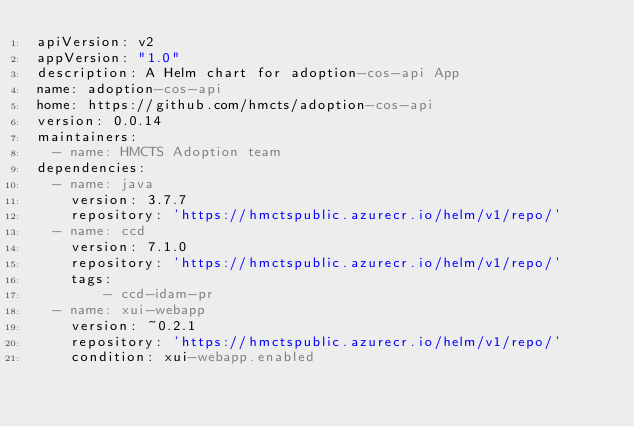<code> <loc_0><loc_0><loc_500><loc_500><_YAML_>apiVersion: v2
appVersion: "1.0"
description: A Helm chart for adoption-cos-api App
name: adoption-cos-api
home: https://github.com/hmcts/adoption-cos-api
version: 0.0.14
maintainers:
  - name: HMCTS Adoption team
dependencies:
  - name: java
    version: 3.7.7
    repository: 'https://hmctspublic.azurecr.io/helm/v1/repo/'
  - name: ccd
    version: 7.1.0
    repository: 'https://hmctspublic.azurecr.io/helm/v1/repo/'
    tags:
        - ccd-idam-pr
  - name: xui-webapp
    version: ~0.2.1
    repository: 'https://hmctspublic.azurecr.io/helm/v1/repo/'
    condition: xui-webapp.enabled
</code> 